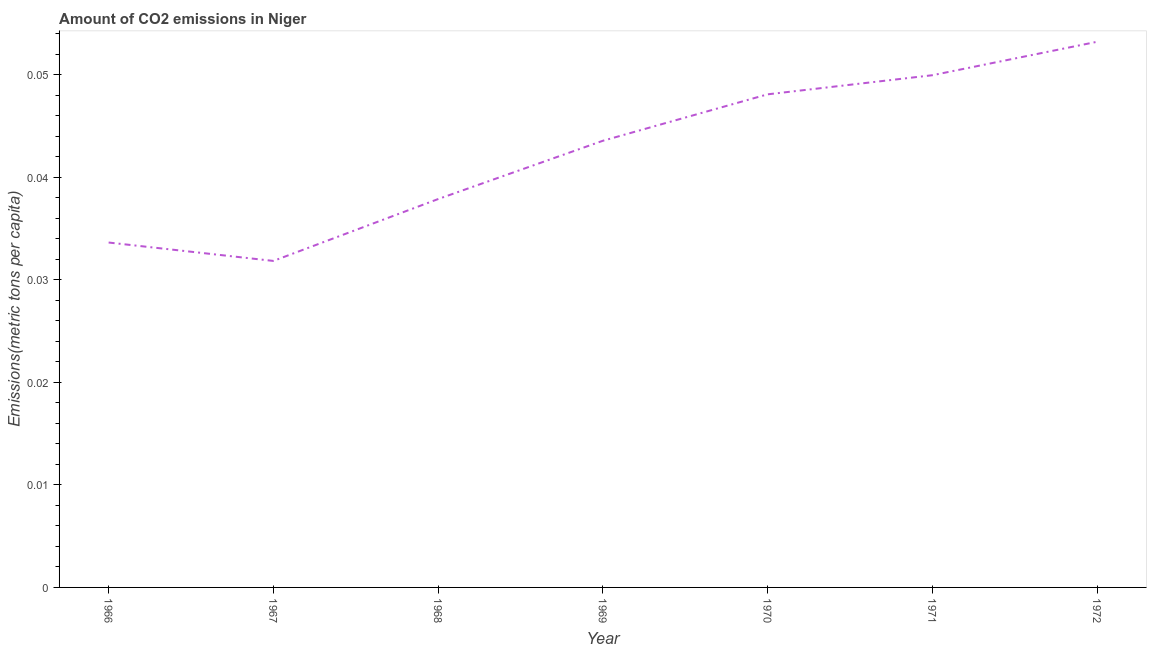What is the amount of co2 emissions in 1966?
Offer a terse response. 0.03. Across all years, what is the maximum amount of co2 emissions?
Offer a very short reply. 0.05. Across all years, what is the minimum amount of co2 emissions?
Give a very brief answer. 0.03. In which year was the amount of co2 emissions minimum?
Keep it short and to the point. 1967. What is the sum of the amount of co2 emissions?
Ensure brevity in your answer.  0.3. What is the difference between the amount of co2 emissions in 1969 and 1972?
Make the answer very short. -0.01. What is the average amount of co2 emissions per year?
Provide a succinct answer. 0.04. What is the median amount of co2 emissions?
Your answer should be compact. 0.04. What is the ratio of the amount of co2 emissions in 1970 to that in 1971?
Provide a short and direct response. 0.96. Is the difference between the amount of co2 emissions in 1969 and 1970 greater than the difference between any two years?
Your response must be concise. No. What is the difference between the highest and the second highest amount of co2 emissions?
Give a very brief answer. 0. What is the difference between the highest and the lowest amount of co2 emissions?
Offer a very short reply. 0.02. In how many years, is the amount of co2 emissions greater than the average amount of co2 emissions taken over all years?
Your answer should be compact. 4. What is the difference between two consecutive major ticks on the Y-axis?
Your answer should be very brief. 0.01. Does the graph contain any zero values?
Provide a short and direct response. No. What is the title of the graph?
Offer a very short reply. Amount of CO2 emissions in Niger. What is the label or title of the X-axis?
Give a very brief answer. Year. What is the label or title of the Y-axis?
Your response must be concise. Emissions(metric tons per capita). What is the Emissions(metric tons per capita) of 1966?
Give a very brief answer. 0.03. What is the Emissions(metric tons per capita) in 1967?
Provide a short and direct response. 0.03. What is the Emissions(metric tons per capita) of 1968?
Offer a very short reply. 0.04. What is the Emissions(metric tons per capita) in 1969?
Keep it short and to the point. 0.04. What is the Emissions(metric tons per capita) in 1970?
Give a very brief answer. 0.05. What is the Emissions(metric tons per capita) in 1971?
Your answer should be compact. 0.05. What is the Emissions(metric tons per capita) in 1972?
Offer a terse response. 0.05. What is the difference between the Emissions(metric tons per capita) in 1966 and 1967?
Give a very brief answer. 0. What is the difference between the Emissions(metric tons per capita) in 1966 and 1968?
Offer a very short reply. -0. What is the difference between the Emissions(metric tons per capita) in 1966 and 1969?
Provide a short and direct response. -0.01. What is the difference between the Emissions(metric tons per capita) in 1966 and 1970?
Offer a very short reply. -0.01. What is the difference between the Emissions(metric tons per capita) in 1966 and 1971?
Your response must be concise. -0.02. What is the difference between the Emissions(metric tons per capita) in 1966 and 1972?
Make the answer very short. -0.02. What is the difference between the Emissions(metric tons per capita) in 1967 and 1968?
Your answer should be compact. -0.01. What is the difference between the Emissions(metric tons per capita) in 1967 and 1969?
Keep it short and to the point. -0.01. What is the difference between the Emissions(metric tons per capita) in 1967 and 1970?
Provide a succinct answer. -0.02. What is the difference between the Emissions(metric tons per capita) in 1967 and 1971?
Keep it short and to the point. -0.02. What is the difference between the Emissions(metric tons per capita) in 1967 and 1972?
Offer a very short reply. -0.02. What is the difference between the Emissions(metric tons per capita) in 1968 and 1969?
Keep it short and to the point. -0.01. What is the difference between the Emissions(metric tons per capita) in 1968 and 1970?
Make the answer very short. -0.01. What is the difference between the Emissions(metric tons per capita) in 1968 and 1971?
Your response must be concise. -0.01. What is the difference between the Emissions(metric tons per capita) in 1968 and 1972?
Provide a succinct answer. -0.02. What is the difference between the Emissions(metric tons per capita) in 1969 and 1970?
Ensure brevity in your answer.  -0. What is the difference between the Emissions(metric tons per capita) in 1969 and 1971?
Make the answer very short. -0.01. What is the difference between the Emissions(metric tons per capita) in 1969 and 1972?
Keep it short and to the point. -0.01. What is the difference between the Emissions(metric tons per capita) in 1970 and 1971?
Offer a terse response. -0. What is the difference between the Emissions(metric tons per capita) in 1970 and 1972?
Give a very brief answer. -0.01. What is the difference between the Emissions(metric tons per capita) in 1971 and 1972?
Make the answer very short. -0. What is the ratio of the Emissions(metric tons per capita) in 1966 to that in 1967?
Provide a short and direct response. 1.06. What is the ratio of the Emissions(metric tons per capita) in 1966 to that in 1968?
Ensure brevity in your answer.  0.89. What is the ratio of the Emissions(metric tons per capita) in 1966 to that in 1969?
Your answer should be very brief. 0.77. What is the ratio of the Emissions(metric tons per capita) in 1966 to that in 1970?
Provide a succinct answer. 0.7. What is the ratio of the Emissions(metric tons per capita) in 1966 to that in 1971?
Your response must be concise. 0.67. What is the ratio of the Emissions(metric tons per capita) in 1966 to that in 1972?
Provide a short and direct response. 0.63. What is the ratio of the Emissions(metric tons per capita) in 1967 to that in 1968?
Provide a short and direct response. 0.84. What is the ratio of the Emissions(metric tons per capita) in 1967 to that in 1969?
Offer a very short reply. 0.73. What is the ratio of the Emissions(metric tons per capita) in 1967 to that in 1970?
Offer a very short reply. 0.66. What is the ratio of the Emissions(metric tons per capita) in 1967 to that in 1971?
Offer a very short reply. 0.64. What is the ratio of the Emissions(metric tons per capita) in 1967 to that in 1972?
Offer a terse response. 0.6. What is the ratio of the Emissions(metric tons per capita) in 1968 to that in 1969?
Provide a short and direct response. 0.87. What is the ratio of the Emissions(metric tons per capita) in 1968 to that in 1970?
Make the answer very short. 0.79. What is the ratio of the Emissions(metric tons per capita) in 1968 to that in 1971?
Make the answer very short. 0.76. What is the ratio of the Emissions(metric tons per capita) in 1968 to that in 1972?
Ensure brevity in your answer.  0.71. What is the ratio of the Emissions(metric tons per capita) in 1969 to that in 1970?
Keep it short and to the point. 0.91. What is the ratio of the Emissions(metric tons per capita) in 1969 to that in 1971?
Offer a terse response. 0.87. What is the ratio of the Emissions(metric tons per capita) in 1969 to that in 1972?
Your answer should be very brief. 0.82. What is the ratio of the Emissions(metric tons per capita) in 1970 to that in 1971?
Provide a succinct answer. 0.96. What is the ratio of the Emissions(metric tons per capita) in 1970 to that in 1972?
Provide a succinct answer. 0.9. What is the ratio of the Emissions(metric tons per capita) in 1971 to that in 1972?
Ensure brevity in your answer.  0.94. 